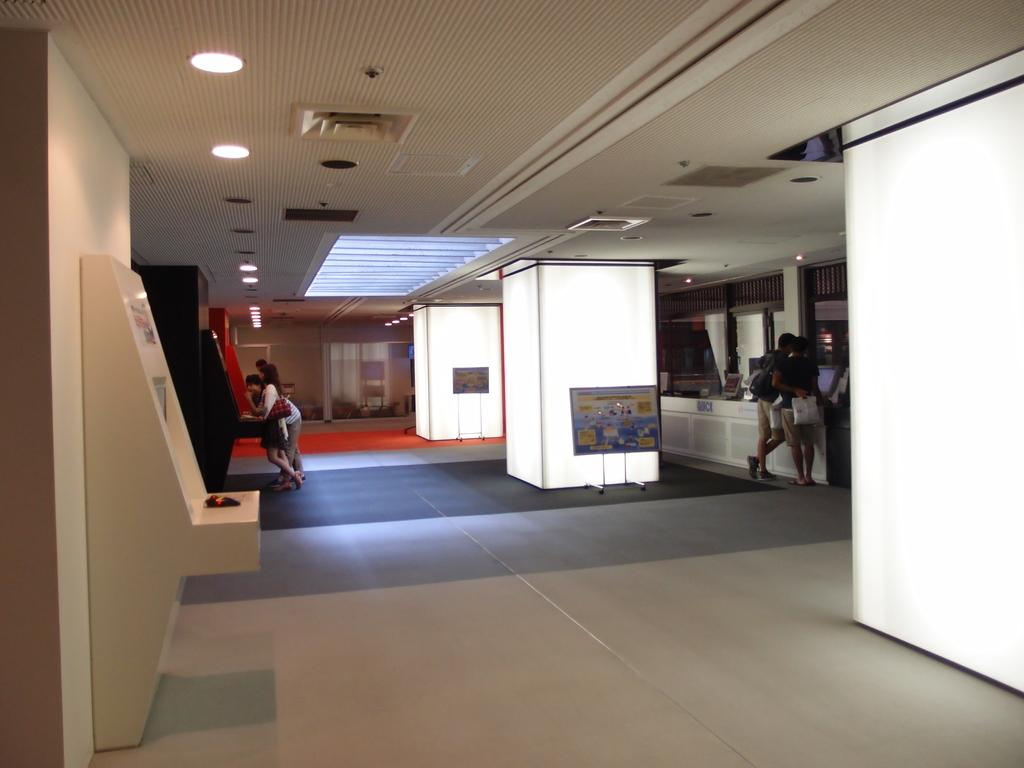Where was the image taken? The image was taken inside a room. What can be seen at the top of the room? There are lights at the top of the room. What is happening in the middle of the room? There are people standing in the middle of the room. What type of list is being discussed by the people in the image? There is no list being discussed in the image; the people are simply standing in the middle of the room. 